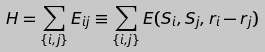<formula> <loc_0><loc_0><loc_500><loc_500>H = \sum _ { \{ i , j \} } E _ { i j } \equiv \sum _ { \{ i , j \} } E ( { S } _ { i } , { S } _ { j } , { r } _ { i } - { r } _ { j } )</formula> 